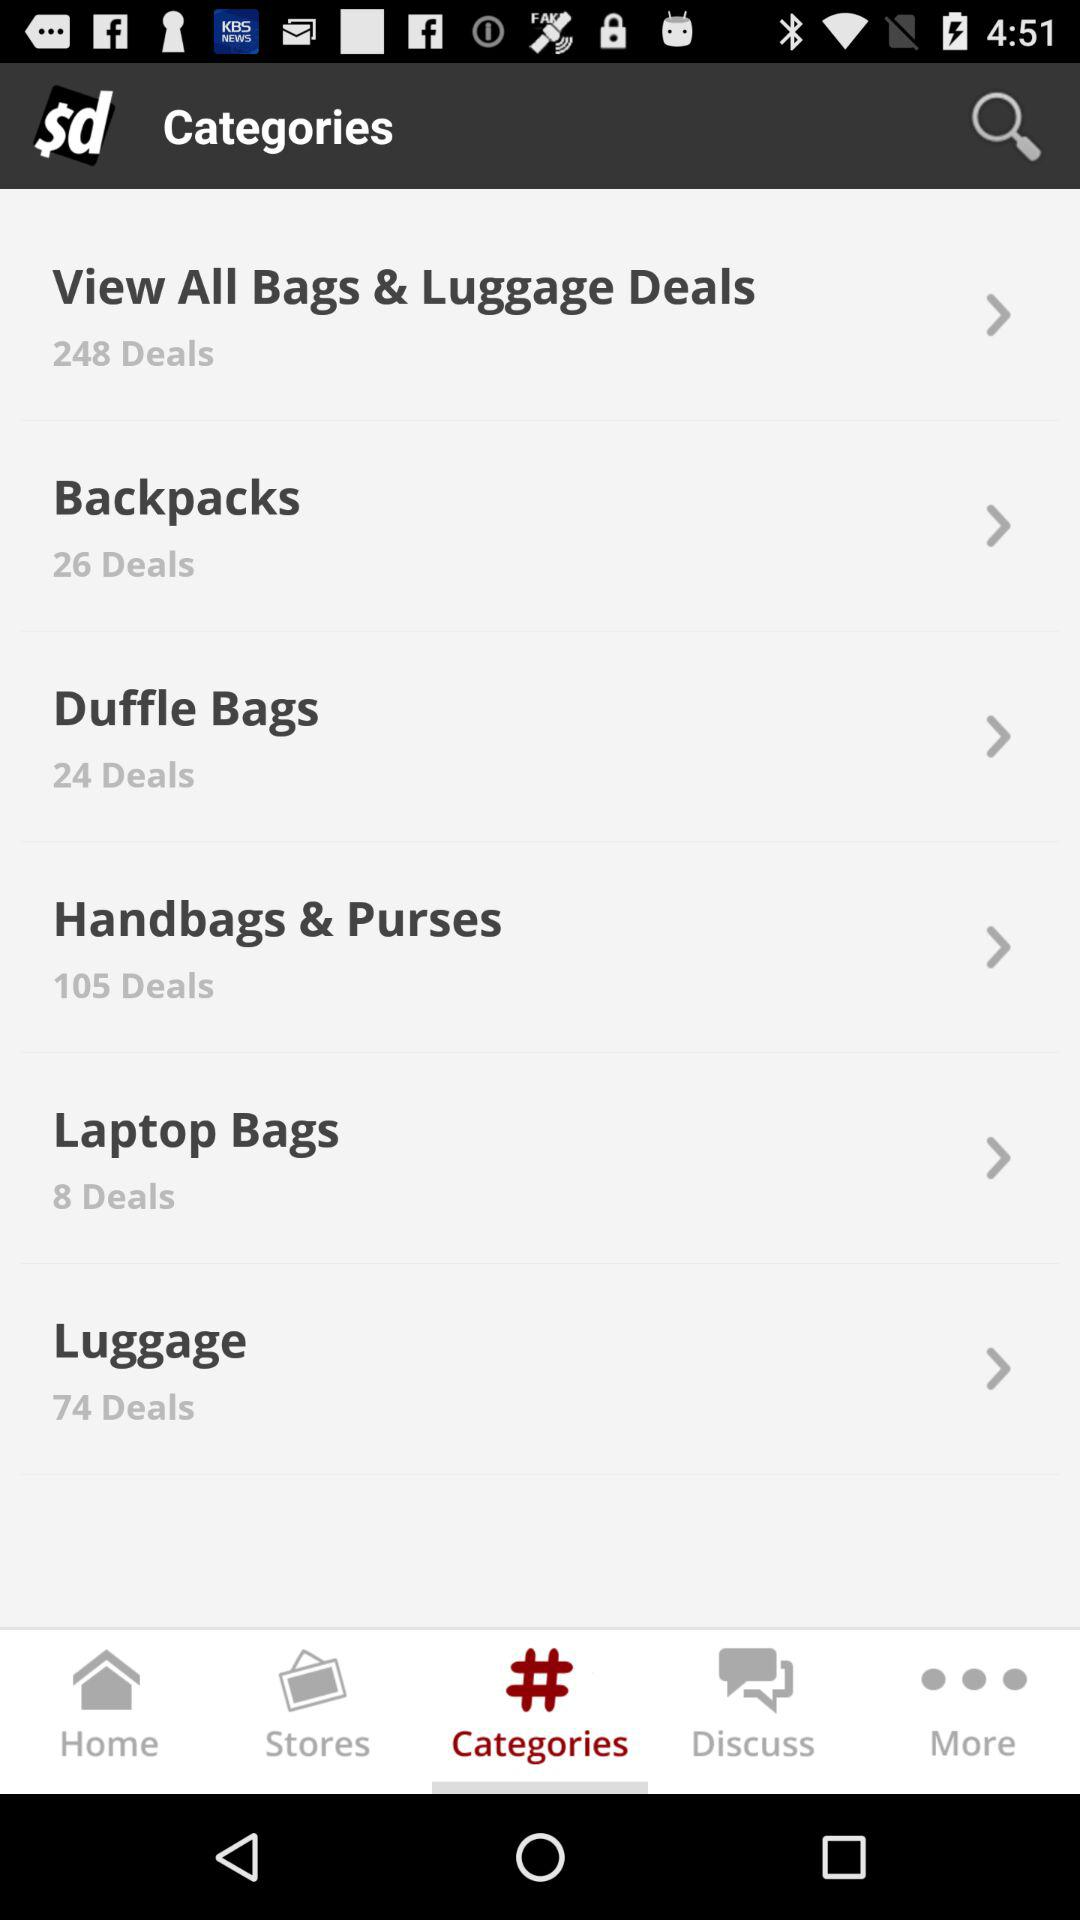How many deals for the duffle bag? There are 24 deals for the duffle bag. 